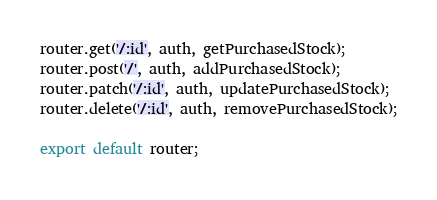Convert code to text. <code><loc_0><loc_0><loc_500><loc_500><_JavaScript_>router.get('/:id', auth, getPurchasedStock);
router.post('/', auth, addPurchasedStock);
router.patch('/:id', auth, updatePurchasedStock);
router.delete('/:id', auth, removePurchasedStock);

export default router;
</code> 